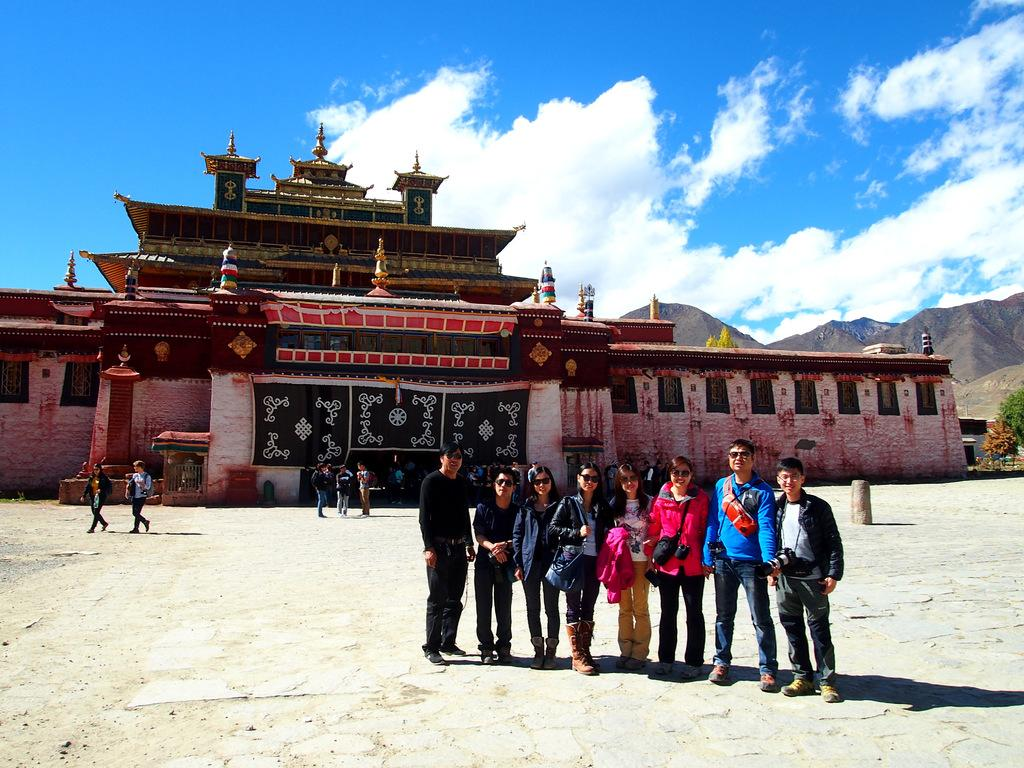How many people are in the image? There is a group of people standing in the image. What type of structure can be seen in the image? There is a building in the image. What other natural elements are present in the image? There are trees and mountains in the image. What can be seen in the background of the image? The sky is visible in the background of the image. Where is the library located in the image? There is no library present in the image. What type of jar is being used by the people in the image? There is no jar visible in the image. 